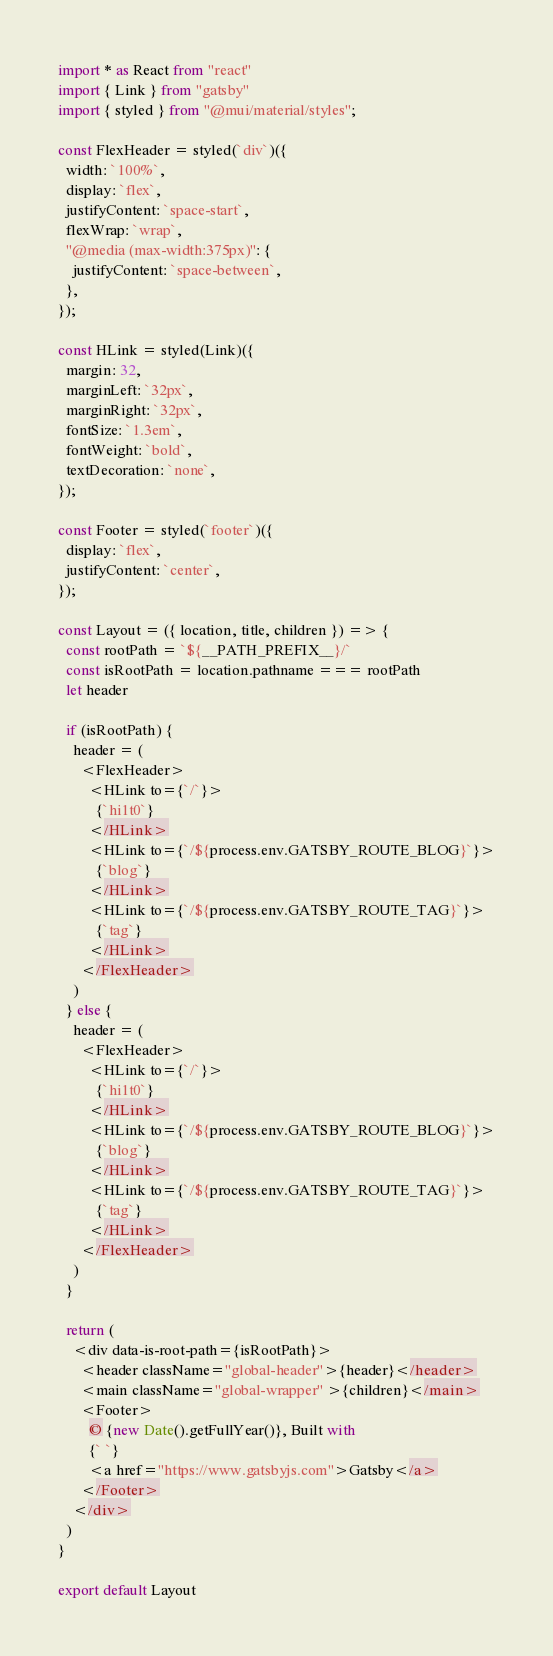Convert code to text. <code><loc_0><loc_0><loc_500><loc_500><_JavaScript_>import * as React from "react"
import { Link } from "gatsby"
import { styled } from "@mui/material/styles";

const FlexHeader = styled(`div`)({
  width: `100%`,
  display: `flex`,
  justifyContent: `space-start`,
  flexWrap: `wrap`,
  "@media (max-width:375px)": {
    justifyContent: `space-between`,
  },
});

const HLink = styled(Link)({
  margin: 32,
  marginLeft: `32px`,
  marginRight: `32px`,
  fontSize: `1.3em`,
  fontWeight: `bold`,
  textDecoration: `none`,
});

const Footer = styled(`footer`)({
  display: `flex`,
  justifyContent: `center`,
});

const Layout = ({ location, title, children }) => {
  const rootPath = `${__PATH_PREFIX__}/`
  const isRootPath = location.pathname === rootPath
  let header

  if (isRootPath) {
    header = (
      <FlexHeader>
        <HLink to={`/`}>
          {`hi1t0`}
        </HLink>
        <HLink to={`/${process.env.GATSBY_ROUTE_BLOG}`}>
          {`blog`}
        </HLink>
        <HLink to={`/${process.env.GATSBY_ROUTE_TAG}`}>
          {`tag`}
        </HLink>
      </FlexHeader>
    )
  } else {
    header = (
      <FlexHeader>
        <HLink to={`/`}>
          {`hi1t0`}
        </HLink>
        <HLink to={`/${process.env.GATSBY_ROUTE_BLOG}`}>
          {`blog`}
        </HLink>
        <HLink to={`/${process.env.GATSBY_ROUTE_TAG}`}>
          {`tag`}
        </HLink>
      </FlexHeader>
    )
  }

  return (
    <div data-is-root-path={isRootPath}>
      <header className="global-header">{header}</header>
      <main className="global-wrapper" >{children}</main>
      <Footer>
        © {new Date().getFullYear()}, Built with
        {` `}
        <a href="https://www.gatsbyjs.com">Gatsby</a>
      </Footer>
    </div>
  )
}

export default Layout
</code> 